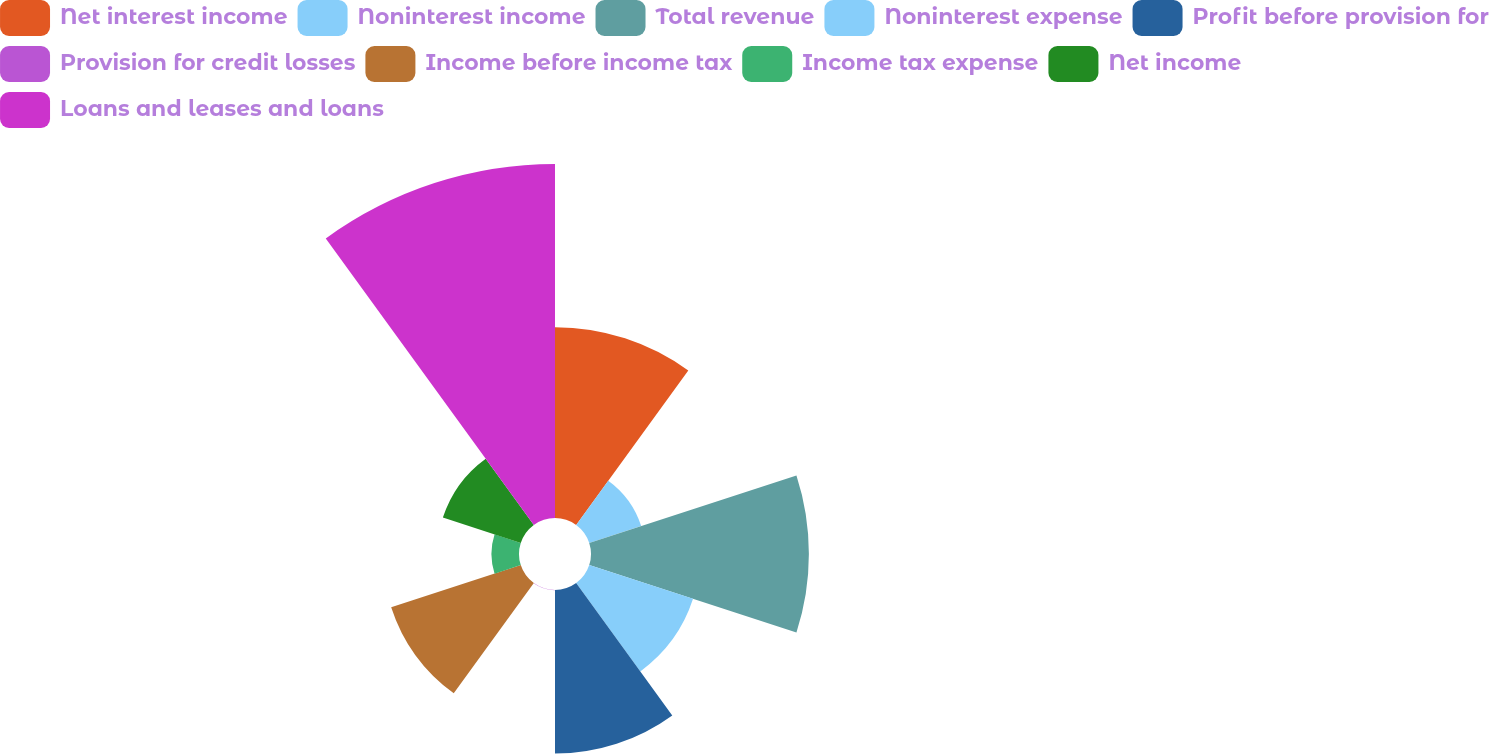Convert chart. <chart><loc_0><loc_0><loc_500><loc_500><pie_chart><fcel>Net interest income<fcel>Noninterest income<fcel>Total revenue<fcel>Noninterest expense<fcel>Profit before provision for<fcel>Provision for credit losses<fcel>Income before income tax<fcel>Income tax expense<fcel>Net income<fcel>Loans and leases and loans<nl><fcel>14.28%<fcel>4.09%<fcel>16.31%<fcel>8.17%<fcel>12.24%<fcel>0.02%<fcel>10.2%<fcel>2.06%<fcel>6.13%<fcel>26.5%<nl></chart> 